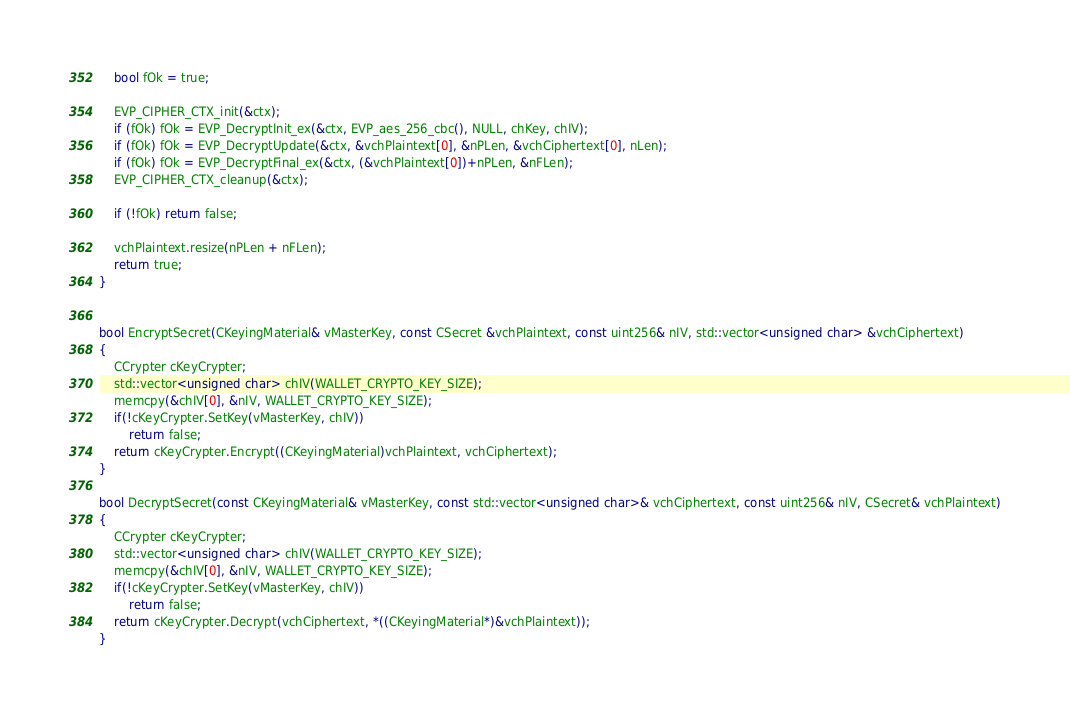Convert code to text. <code><loc_0><loc_0><loc_500><loc_500><_C++_>
    bool fOk = true;

    EVP_CIPHER_CTX_init(&ctx);
    if (fOk) fOk = EVP_DecryptInit_ex(&ctx, EVP_aes_256_cbc(), NULL, chKey, chIV);
    if (fOk) fOk = EVP_DecryptUpdate(&ctx, &vchPlaintext[0], &nPLen, &vchCiphertext[0], nLen);
    if (fOk) fOk = EVP_DecryptFinal_ex(&ctx, (&vchPlaintext[0])+nPLen, &nFLen);
    EVP_CIPHER_CTX_cleanup(&ctx);

    if (!fOk) return false;

    vchPlaintext.resize(nPLen + nFLen);
    return true;
}


bool EncryptSecret(CKeyingMaterial& vMasterKey, const CSecret &vchPlaintext, const uint256& nIV, std::vector<unsigned char> &vchCiphertext)
{
    CCrypter cKeyCrypter;
    std::vector<unsigned char> chIV(WALLET_CRYPTO_KEY_SIZE);
    memcpy(&chIV[0], &nIV, WALLET_CRYPTO_KEY_SIZE);
    if(!cKeyCrypter.SetKey(vMasterKey, chIV))
        return false;
    return cKeyCrypter.Encrypt((CKeyingMaterial)vchPlaintext, vchCiphertext);
}

bool DecryptSecret(const CKeyingMaterial& vMasterKey, const std::vector<unsigned char>& vchCiphertext, const uint256& nIV, CSecret& vchPlaintext)
{
    CCrypter cKeyCrypter;
    std::vector<unsigned char> chIV(WALLET_CRYPTO_KEY_SIZE);
    memcpy(&chIV[0], &nIV, WALLET_CRYPTO_KEY_SIZE);
    if(!cKeyCrypter.SetKey(vMasterKey, chIV))
        return false;
    return cKeyCrypter.Decrypt(vchCiphertext, *((CKeyingMaterial*)&vchPlaintext));
}
</code> 